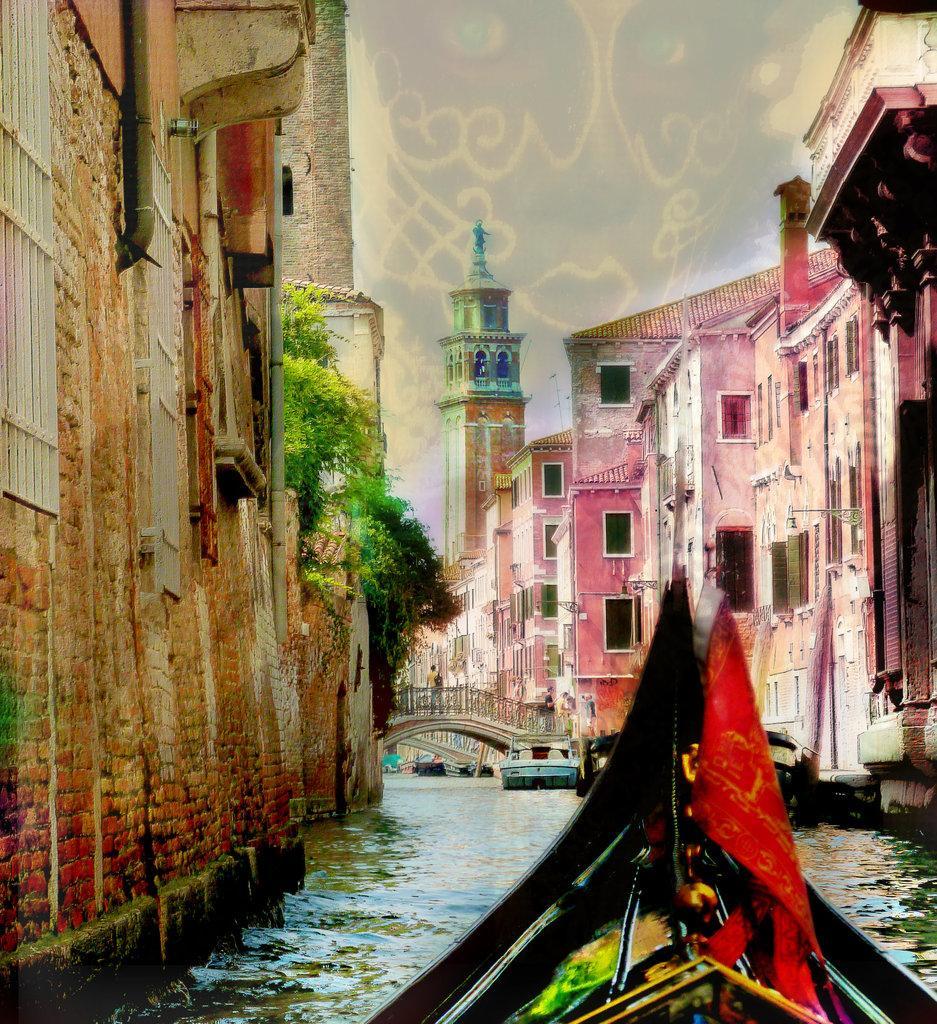Can you describe this image briefly? In this image I can see few boats on the water, background I can see few buildings in brown, white and cream color and I can see the trees in green color and the sky is in white color. 